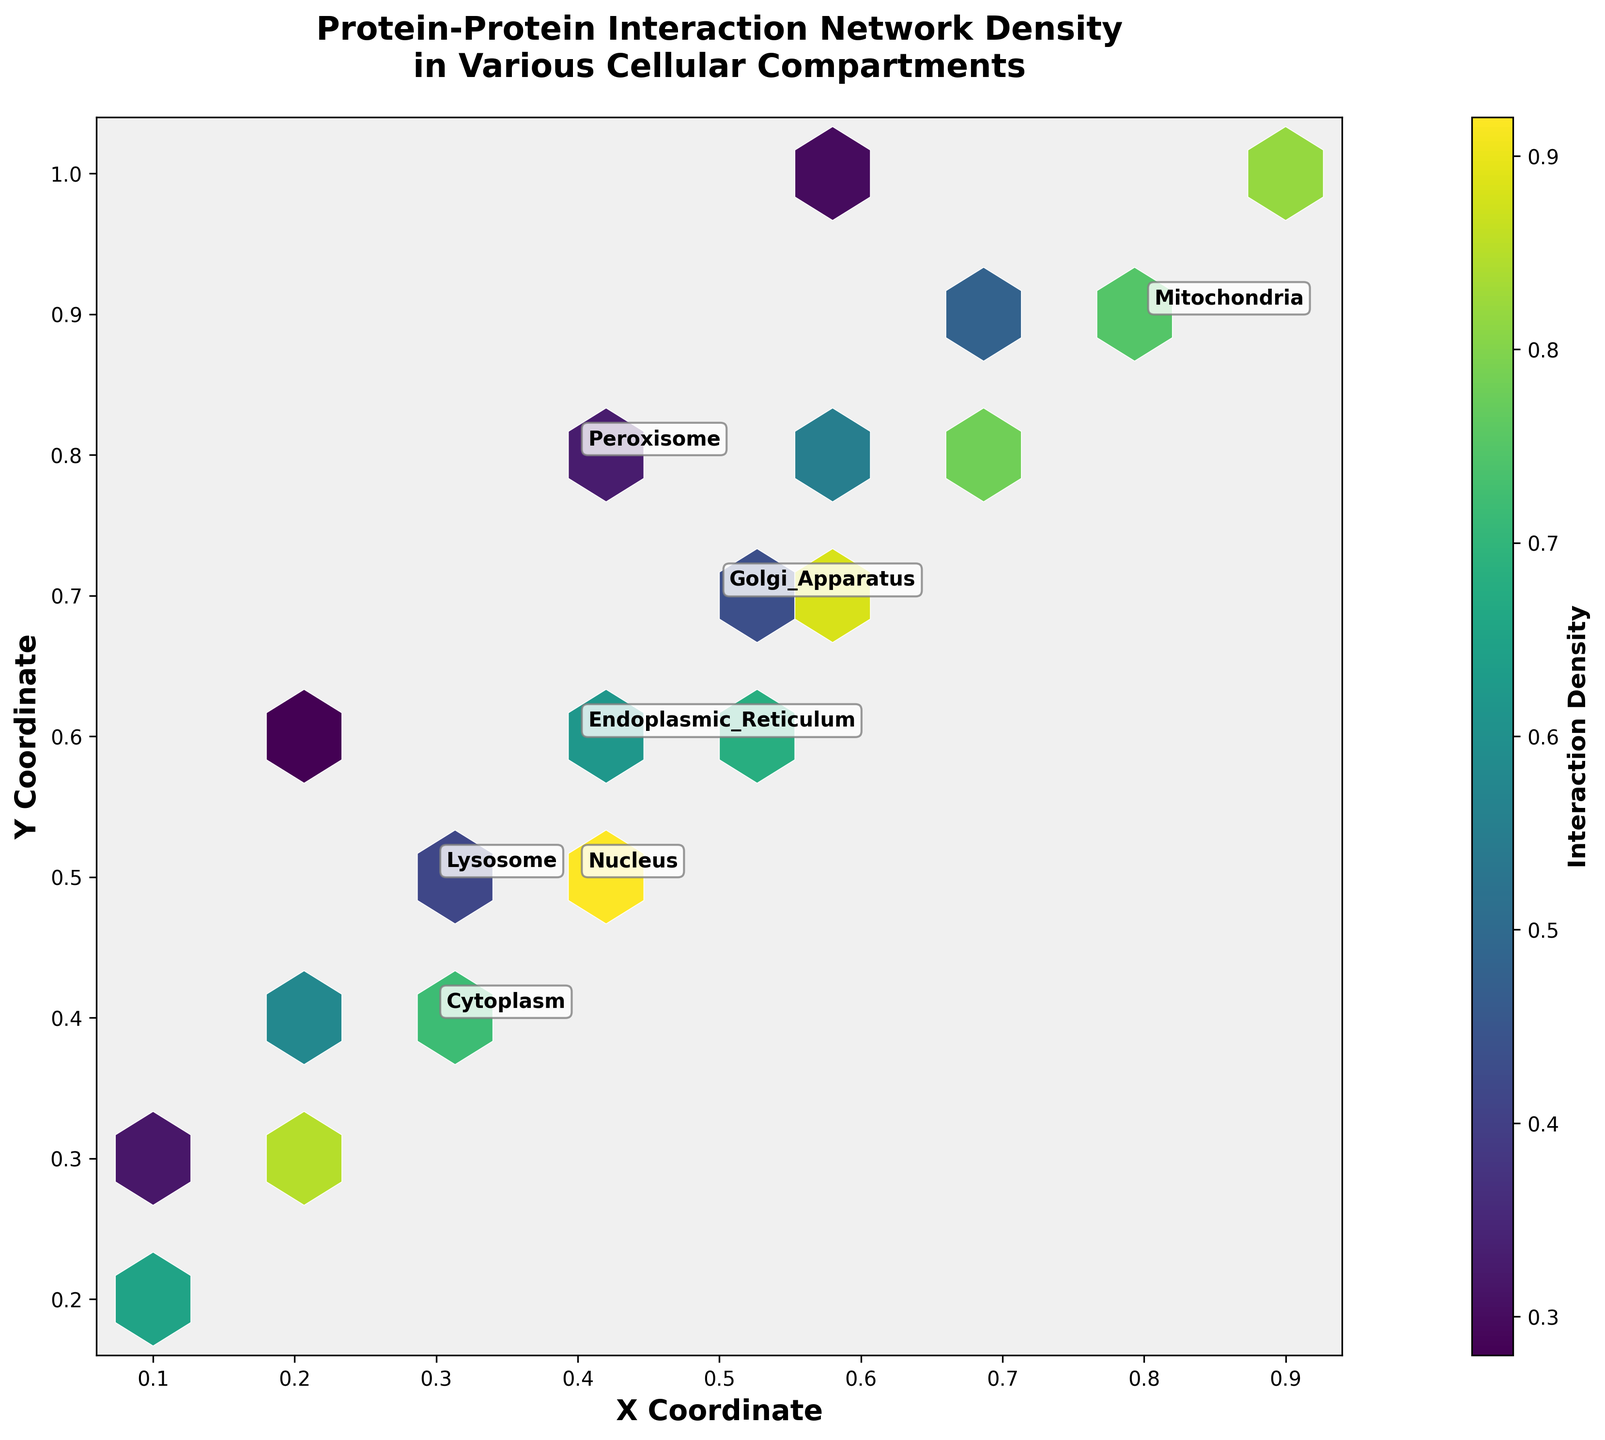What is the title of the hexbin plot? The title can be found at the top of the plot. It reads "Protein-Protein Interaction Network Density in Various Cellular Compartments."
Answer: Protein-Protein Interaction Network Density in Various Cellular Compartments What do the color variations in the hexagons represent? In a hexbin plot, color variations typically indicate different values of an additional data dimension. In this plot, the colors represent "Interaction Density," with the color bar showing how density values map to colors.
Answer: Interaction Density Which cellular compartment has the highest average interaction density? From the text annotations, we can identify the coordinates for each compartment. Comparing their average densities, Nucleus shows coordinates (0.4, 0.5) with the highest average density of 0.92 among the data points.
Answer: Nucleus What are the axis labels on the plot? The labels on the X and Y axes provide information about the dimensions being represented. The X-axis is labeled 'X Coordinate' and the Y-axis is labeled 'Y Coordinate.'
Answer: X Coordinate and Y Coordinate How many distinct cellular compartments are annotated in the plot? The annotations represent unique compartments. Counting the labels shown, we find: Nucleus, Cytoplasm, Mitochondria, Endoplasmic Reticulum, Golgi Apparatus, Lysosome, and Peroxisome.
Answer: 7 What does the color bar indicate on the right side of the plot? The color bar indicates the range of interaction density values. It helps map the colors in the hexbin plot to numerical values of interaction density.
Answer: Interaction Density range Comparing Mitochondria and Lysosome, which has higher average interaction density? Looking at the coordinates and densities, Mitochondria has values around (0.8, 0.9) with densities around 0.78 and above, whereas Lysosome has lower densities around 0.32. Therefore, Mitochondria has a higher average interaction density.
Answer: Mitochondria In which compartment are protein-protein interactions the least dense on average? Observing the compartment with the lowest density values based on the color, Peroxisome has average interaction densities (0.28 to 0.33), which are the lowest among all compartments.
Answer: Peroxisome What is the relationship between X and Y coordinates and interaction density in the Nucleus? Checking the coordinates (0.2, 0.3), (0.4, 0.5), and (0.6, 0.7), the densest interaction is at (0.4, 0.5). The density is generally high regardless of the specific point.
Answer: High density What range of interaction density do most hexagons fall into? Observing the color intensity, most hexagons range between medium to high interaction density values, which the color bar shows roughly spans from approximately 0.4 to 0.8.
Answer: 0.4 to 0.8 